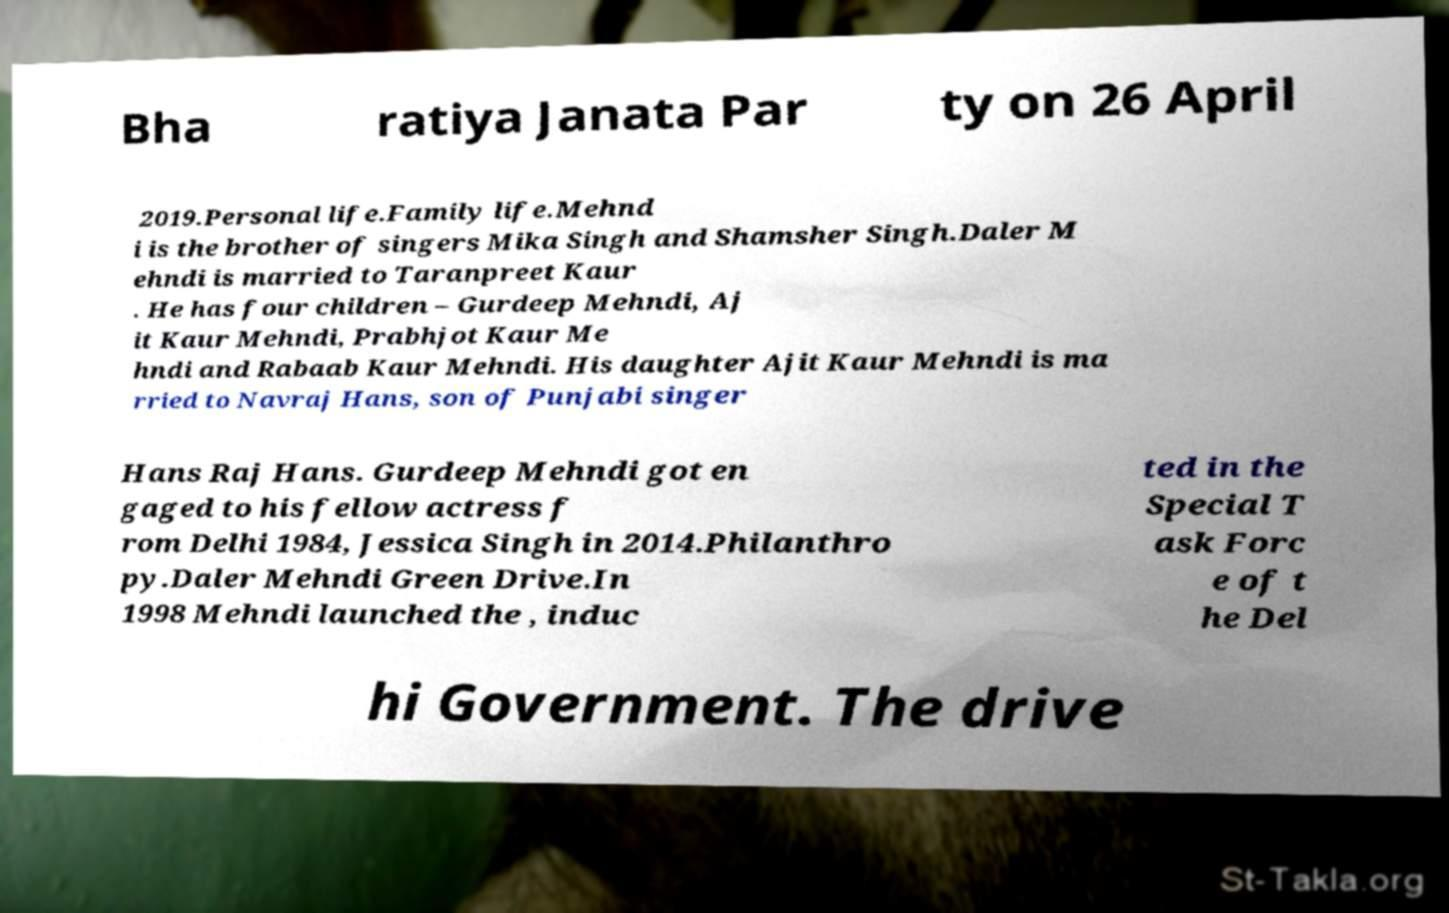Could you assist in decoding the text presented in this image and type it out clearly? Bha ratiya Janata Par ty on 26 April 2019.Personal life.Family life.Mehnd i is the brother of singers Mika Singh and Shamsher Singh.Daler M ehndi is married to Taranpreet Kaur . He has four children – Gurdeep Mehndi, Aj it Kaur Mehndi, Prabhjot Kaur Me hndi and Rabaab Kaur Mehndi. His daughter Ajit Kaur Mehndi is ma rried to Navraj Hans, son of Punjabi singer Hans Raj Hans. Gurdeep Mehndi got en gaged to his fellow actress f rom Delhi 1984, Jessica Singh in 2014.Philanthro py.Daler Mehndi Green Drive.In 1998 Mehndi launched the , induc ted in the Special T ask Forc e of t he Del hi Government. The drive 